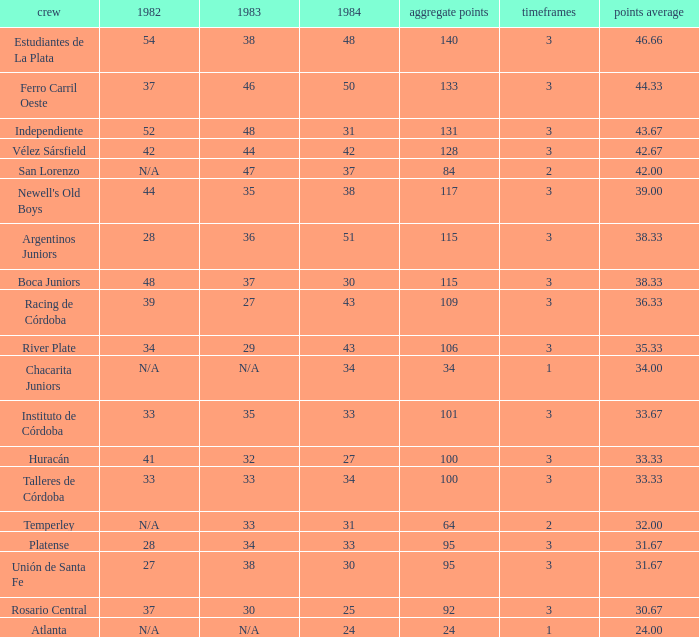What is the number of seasons for the team with a total fewer than 24? None. 